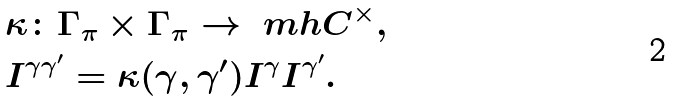Convert formula to latex. <formula><loc_0><loc_0><loc_500><loc_500>& \kappa \colon \Gamma _ { \pi } \times \Gamma _ { \pi } \to \ m h C ^ { \times } , \\ & I ^ { \gamma \gamma ^ { \prime } } = \kappa ( \gamma , \gamma ^ { \prime } ) I ^ { \gamma } I ^ { \gamma ^ { \prime } } .</formula> 